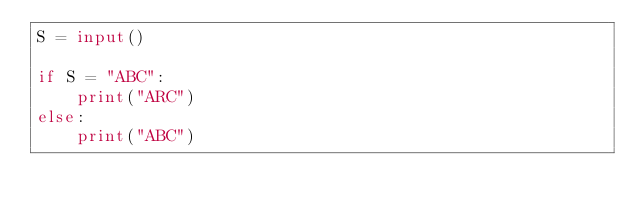Convert code to text. <code><loc_0><loc_0><loc_500><loc_500><_Python_>S = input()

if S = "ABC":
    print("ARC")
else:
    print("ABC")
</code> 